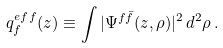Convert formula to latex. <formula><loc_0><loc_0><loc_500><loc_500>q _ { f } ^ { e f f } ( z ) \equiv \int | \Psi ^ { f \bar { f } } ( z , \rho ) | ^ { 2 } \, d ^ { 2 } \rho \, .</formula> 